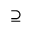Convert formula to latex. <formula><loc_0><loc_0><loc_500><loc_500>\supseteq</formula> 